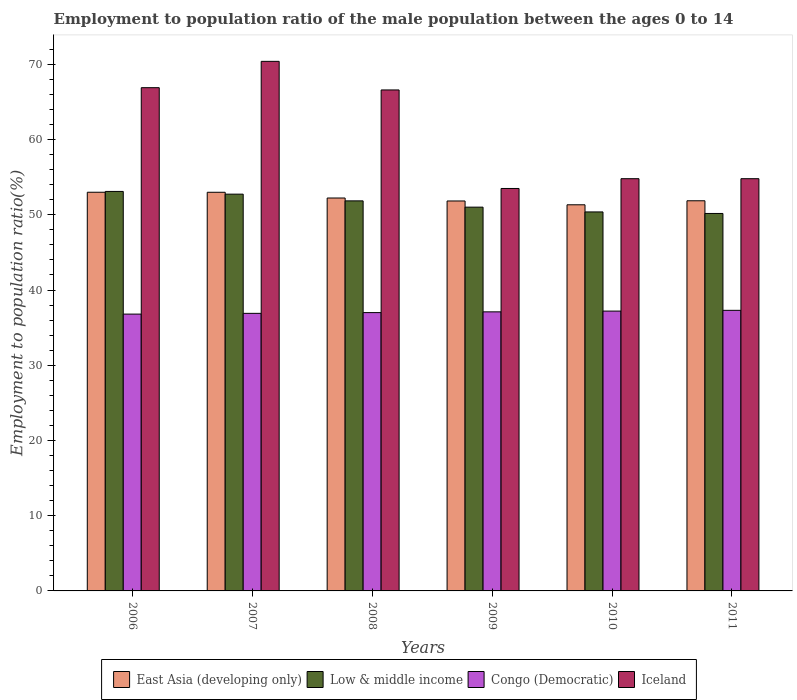How many different coloured bars are there?
Offer a very short reply. 4. Are the number of bars per tick equal to the number of legend labels?
Provide a short and direct response. Yes. How many bars are there on the 5th tick from the right?
Offer a terse response. 4. What is the label of the 3rd group of bars from the left?
Your answer should be compact. 2008. What is the employment to population ratio in East Asia (developing only) in 2009?
Ensure brevity in your answer.  51.84. Across all years, what is the maximum employment to population ratio in Congo (Democratic)?
Offer a very short reply. 37.3. Across all years, what is the minimum employment to population ratio in Low & middle income?
Provide a succinct answer. 50.18. In which year was the employment to population ratio in East Asia (developing only) maximum?
Provide a succinct answer. 2006. What is the total employment to population ratio in Iceland in the graph?
Give a very brief answer. 367. What is the difference between the employment to population ratio in Low & middle income in 2010 and that in 2011?
Your answer should be compact. 0.21. What is the difference between the employment to population ratio in Iceland in 2008 and the employment to population ratio in Congo (Democratic) in 2007?
Give a very brief answer. 29.7. What is the average employment to population ratio in Low & middle income per year?
Your answer should be very brief. 51.55. In the year 2010, what is the difference between the employment to population ratio in Iceland and employment to population ratio in East Asia (developing only)?
Your response must be concise. 3.47. What is the ratio of the employment to population ratio in East Asia (developing only) in 2007 to that in 2008?
Keep it short and to the point. 1.01. Is the employment to population ratio in East Asia (developing only) in 2007 less than that in 2009?
Offer a terse response. No. What is the difference between the highest and the second highest employment to population ratio in East Asia (developing only)?
Offer a very short reply. 0. What is the difference between the highest and the lowest employment to population ratio in East Asia (developing only)?
Provide a short and direct response. 1.67. In how many years, is the employment to population ratio in Iceland greater than the average employment to population ratio in Iceland taken over all years?
Provide a succinct answer. 3. Is it the case that in every year, the sum of the employment to population ratio in East Asia (developing only) and employment to population ratio in Congo (Democratic) is greater than the sum of employment to population ratio in Iceland and employment to population ratio in Low & middle income?
Your answer should be very brief. No. What does the 1st bar from the left in 2007 represents?
Your answer should be compact. East Asia (developing only). What does the 3rd bar from the right in 2006 represents?
Your answer should be compact. Low & middle income. Is it the case that in every year, the sum of the employment to population ratio in Iceland and employment to population ratio in East Asia (developing only) is greater than the employment to population ratio in Congo (Democratic)?
Your answer should be very brief. Yes. Are the values on the major ticks of Y-axis written in scientific E-notation?
Make the answer very short. No. Does the graph contain any zero values?
Your answer should be very brief. No. Where does the legend appear in the graph?
Offer a very short reply. Bottom center. How are the legend labels stacked?
Ensure brevity in your answer.  Horizontal. What is the title of the graph?
Your answer should be very brief. Employment to population ratio of the male population between the ages 0 to 14. Does "Oman" appear as one of the legend labels in the graph?
Provide a short and direct response. No. What is the label or title of the Y-axis?
Keep it short and to the point. Employment to population ratio(%). What is the Employment to population ratio(%) of East Asia (developing only) in 2006?
Ensure brevity in your answer.  53. What is the Employment to population ratio(%) of Low & middle income in 2006?
Offer a terse response. 53.11. What is the Employment to population ratio(%) of Congo (Democratic) in 2006?
Keep it short and to the point. 36.8. What is the Employment to population ratio(%) in Iceland in 2006?
Provide a short and direct response. 66.9. What is the Employment to population ratio(%) in East Asia (developing only) in 2007?
Your answer should be compact. 53. What is the Employment to population ratio(%) in Low & middle income in 2007?
Your response must be concise. 52.75. What is the Employment to population ratio(%) of Congo (Democratic) in 2007?
Your answer should be very brief. 36.9. What is the Employment to population ratio(%) in Iceland in 2007?
Make the answer very short. 70.4. What is the Employment to population ratio(%) of East Asia (developing only) in 2008?
Offer a very short reply. 52.23. What is the Employment to population ratio(%) in Low & middle income in 2008?
Your answer should be compact. 51.85. What is the Employment to population ratio(%) of Iceland in 2008?
Give a very brief answer. 66.6. What is the Employment to population ratio(%) in East Asia (developing only) in 2009?
Give a very brief answer. 51.84. What is the Employment to population ratio(%) in Low & middle income in 2009?
Keep it short and to the point. 51.02. What is the Employment to population ratio(%) in Congo (Democratic) in 2009?
Your answer should be very brief. 37.1. What is the Employment to population ratio(%) of Iceland in 2009?
Offer a terse response. 53.5. What is the Employment to population ratio(%) of East Asia (developing only) in 2010?
Your answer should be compact. 51.33. What is the Employment to population ratio(%) in Low & middle income in 2010?
Offer a very short reply. 50.38. What is the Employment to population ratio(%) of Congo (Democratic) in 2010?
Your response must be concise. 37.2. What is the Employment to population ratio(%) of Iceland in 2010?
Make the answer very short. 54.8. What is the Employment to population ratio(%) of East Asia (developing only) in 2011?
Provide a short and direct response. 51.87. What is the Employment to population ratio(%) of Low & middle income in 2011?
Your answer should be compact. 50.18. What is the Employment to population ratio(%) of Congo (Democratic) in 2011?
Offer a very short reply. 37.3. What is the Employment to population ratio(%) of Iceland in 2011?
Ensure brevity in your answer.  54.8. Across all years, what is the maximum Employment to population ratio(%) of East Asia (developing only)?
Keep it short and to the point. 53. Across all years, what is the maximum Employment to population ratio(%) in Low & middle income?
Provide a succinct answer. 53.11. Across all years, what is the maximum Employment to population ratio(%) in Congo (Democratic)?
Offer a very short reply. 37.3. Across all years, what is the maximum Employment to population ratio(%) of Iceland?
Ensure brevity in your answer.  70.4. Across all years, what is the minimum Employment to population ratio(%) of East Asia (developing only)?
Your response must be concise. 51.33. Across all years, what is the minimum Employment to population ratio(%) of Low & middle income?
Make the answer very short. 50.18. Across all years, what is the minimum Employment to population ratio(%) of Congo (Democratic)?
Ensure brevity in your answer.  36.8. Across all years, what is the minimum Employment to population ratio(%) in Iceland?
Offer a terse response. 53.5. What is the total Employment to population ratio(%) in East Asia (developing only) in the graph?
Provide a succinct answer. 313.27. What is the total Employment to population ratio(%) in Low & middle income in the graph?
Your response must be concise. 309.29. What is the total Employment to population ratio(%) in Congo (Democratic) in the graph?
Keep it short and to the point. 222.3. What is the total Employment to population ratio(%) of Iceland in the graph?
Your answer should be compact. 367. What is the difference between the Employment to population ratio(%) of East Asia (developing only) in 2006 and that in 2007?
Give a very brief answer. 0. What is the difference between the Employment to population ratio(%) of Low & middle income in 2006 and that in 2007?
Offer a very short reply. 0.36. What is the difference between the Employment to population ratio(%) in East Asia (developing only) in 2006 and that in 2008?
Ensure brevity in your answer.  0.77. What is the difference between the Employment to population ratio(%) in Low & middle income in 2006 and that in 2008?
Offer a very short reply. 1.26. What is the difference between the Employment to population ratio(%) in Congo (Democratic) in 2006 and that in 2008?
Your response must be concise. -0.2. What is the difference between the Employment to population ratio(%) of Iceland in 2006 and that in 2008?
Your answer should be very brief. 0.3. What is the difference between the Employment to population ratio(%) in East Asia (developing only) in 2006 and that in 2009?
Give a very brief answer. 1.16. What is the difference between the Employment to population ratio(%) of Low & middle income in 2006 and that in 2009?
Give a very brief answer. 2.09. What is the difference between the Employment to population ratio(%) in Congo (Democratic) in 2006 and that in 2009?
Keep it short and to the point. -0.3. What is the difference between the Employment to population ratio(%) in East Asia (developing only) in 2006 and that in 2010?
Give a very brief answer. 1.67. What is the difference between the Employment to population ratio(%) in Low & middle income in 2006 and that in 2010?
Offer a very short reply. 2.72. What is the difference between the Employment to population ratio(%) in Congo (Democratic) in 2006 and that in 2010?
Make the answer very short. -0.4. What is the difference between the Employment to population ratio(%) of East Asia (developing only) in 2006 and that in 2011?
Your answer should be compact. 1.13. What is the difference between the Employment to population ratio(%) of Low & middle income in 2006 and that in 2011?
Offer a very short reply. 2.93. What is the difference between the Employment to population ratio(%) of Iceland in 2006 and that in 2011?
Provide a succinct answer. 12.1. What is the difference between the Employment to population ratio(%) in East Asia (developing only) in 2007 and that in 2008?
Make the answer very short. 0.76. What is the difference between the Employment to population ratio(%) in Low & middle income in 2007 and that in 2008?
Make the answer very short. 0.89. What is the difference between the Employment to population ratio(%) in Iceland in 2007 and that in 2008?
Ensure brevity in your answer.  3.8. What is the difference between the Employment to population ratio(%) of East Asia (developing only) in 2007 and that in 2009?
Provide a short and direct response. 1.16. What is the difference between the Employment to population ratio(%) in Low & middle income in 2007 and that in 2009?
Provide a short and direct response. 1.73. What is the difference between the Employment to population ratio(%) in Congo (Democratic) in 2007 and that in 2009?
Make the answer very short. -0.2. What is the difference between the Employment to population ratio(%) of Iceland in 2007 and that in 2009?
Provide a short and direct response. 16.9. What is the difference between the Employment to population ratio(%) of East Asia (developing only) in 2007 and that in 2010?
Provide a short and direct response. 1.66. What is the difference between the Employment to population ratio(%) in Low & middle income in 2007 and that in 2010?
Your response must be concise. 2.36. What is the difference between the Employment to population ratio(%) in Iceland in 2007 and that in 2010?
Keep it short and to the point. 15.6. What is the difference between the Employment to population ratio(%) in East Asia (developing only) in 2007 and that in 2011?
Offer a terse response. 1.13. What is the difference between the Employment to population ratio(%) in Low & middle income in 2007 and that in 2011?
Offer a terse response. 2.57. What is the difference between the Employment to population ratio(%) of East Asia (developing only) in 2008 and that in 2009?
Your answer should be very brief. 0.39. What is the difference between the Employment to population ratio(%) of Low & middle income in 2008 and that in 2009?
Your answer should be compact. 0.83. What is the difference between the Employment to population ratio(%) in Iceland in 2008 and that in 2009?
Provide a short and direct response. 13.1. What is the difference between the Employment to population ratio(%) of East Asia (developing only) in 2008 and that in 2010?
Offer a very short reply. 0.9. What is the difference between the Employment to population ratio(%) of Low & middle income in 2008 and that in 2010?
Ensure brevity in your answer.  1.47. What is the difference between the Employment to population ratio(%) in Iceland in 2008 and that in 2010?
Ensure brevity in your answer.  11.8. What is the difference between the Employment to population ratio(%) of East Asia (developing only) in 2008 and that in 2011?
Your answer should be compact. 0.37. What is the difference between the Employment to population ratio(%) in Low & middle income in 2008 and that in 2011?
Offer a very short reply. 1.67. What is the difference between the Employment to population ratio(%) in Congo (Democratic) in 2008 and that in 2011?
Offer a terse response. -0.3. What is the difference between the Employment to population ratio(%) of Iceland in 2008 and that in 2011?
Your answer should be very brief. 11.8. What is the difference between the Employment to population ratio(%) in East Asia (developing only) in 2009 and that in 2010?
Offer a terse response. 0.51. What is the difference between the Employment to population ratio(%) in Low & middle income in 2009 and that in 2010?
Give a very brief answer. 0.63. What is the difference between the Employment to population ratio(%) of Iceland in 2009 and that in 2010?
Offer a terse response. -1.3. What is the difference between the Employment to population ratio(%) in East Asia (developing only) in 2009 and that in 2011?
Keep it short and to the point. -0.03. What is the difference between the Employment to population ratio(%) in Low & middle income in 2009 and that in 2011?
Provide a short and direct response. 0.84. What is the difference between the Employment to population ratio(%) of East Asia (developing only) in 2010 and that in 2011?
Offer a terse response. -0.53. What is the difference between the Employment to population ratio(%) of Low & middle income in 2010 and that in 2011?
Offer a terse response. 0.21. What is the difference between the Employment to population ratio(%) of East Asia (developing only) in 2006 and the Employment to population ratio(%) of Low & middle income in 2007?
Your answer should be compact. 0.25. What is the difference between the Employment to population ratio(%) in East Asia (developing only) in 2006 and the Employment to population ratio(%) in Congo (Democratic) in 2007?
Make the answer very short. 16.1. What is the difference between the Employment to population ratio(%) of East Asia (developing only) in 2006 and the Employment to population ratio(%) of Iceland in 2007?
Give a very brief answer. -17.4. What is the difference between the Employment to population ratio(%) of Low & middle income in 2006 and the Employment to population ratio(%) of Congo (Democratic) in 2007?
Your answer should be very brief. 16.21. What is the difference between the Employment to population ratio(%) in Low & middle income in 2006 and the Employment to population ratio(%) in Iceland in 2007?
Your answer should be very brief. -17.29. What is the difference between the Employment to population ratio(%) of Congo (Democratic) in 2006 and the Employment to population ratio(%) of Iceland in 2007?
Offer a terse response. -33.6. What is the difference between the Employment to population ratio(%) in East Asia (developing only) in 2006 and the Employment to population ratio(%) in Low & middle income in 2008?
Give a very brief answer. 1.15. What is the difference between the Employment to population ratio(%) in East Asia (developing only) in 2006 and the Employment to population ratio(%) in Congo (Democratic) in 2008?
Your answer should be compact. 16. What is the difference between the Employment to population ratio(%) in East Asia (developing only) in 2006 and the Employment to population ratio(%) in Iceland in 2008?
Make the answer very short. -13.6. What is the difference between the Employment to population ratio(%) of Low & middle income in 2006 and the Employment to population ratio(%) of Congo (Democratic) in 2008?
Your answer should be compact. 16.11. What is the difference between the Employment to population ratio(%) in Low & middle income in 2006 and the Employment to population ratio(%) in Iceland in 2008?
Your answer should be very brief. -13.49. What is the difference between the Employment to population ratio(%) in Congo (Democratic) in 2006 and the Employment to population ratio(%) in Iceland in 2008?
Give a very brief answer. -29.8. What is the difference between the Employment to population ratio(%) in East Asia (developing only) in 2006 and the Employment to population ratio(%) in Low & middle income in 2009?
Provide a succinct answer. 1.98. What is the difference between the Employment to population ratio(%) of East Asia (developing only) in 2006 and the Employment to population ratio(%) of Congo (Democratic) in 2009?
Offer a terse response. 15.9. What is the difference between the Employment to population ratio(%) of East Asia (developing only) in 2006 and the Employment to population ratio(%) of Iceland in 2009?
Provide a short and direct response. -0.5. What is the difference between the Employment to population ratio(%) in Low & middle income in 2006 and the Employment to population ratio(%) in Congo (Democratic) in 2009?
Ensure brevity in your answer.  16.01. What is the difference between the Employment to population ratio(%) of Low & middle income in 2006 and the Employment to population ratio(%) of Iceland in 2009?
Ensure brevity in your answer.  -0.39. What is the difference between the Employment to population ratio(%) of Congo (Democratic) in 2006 and the Employment to population ratio(%) of Iceland in 2009?
Provide a succinct answer. -16.7. What is the difference between the Employment to population ratio(%) of East Asia (developing only) in 2006 and the Employment to population ratio(%) of Low & middle income in 2010?
Your answer should be very brief. 2.62. What is the difference between the Employment to population ratio(%) of East Asia (developing only) in 2006 and the Employment to population ratio(%) of Congo (Democratic) in 2010?
Give a very brief answer. 15.8. What is the difference between the Employment to population ratio(%) of East Asia (developing only) in 2006 and the Employment to population ratio(%) of Iceland in 2010?
Offer a very short reply. -1.8. What is the difference between the Employment to population ratio(%) in Low & middle income in 2006 and the Employment to population ratio(%) in Congo (Democratic) in 2010?
Offer a terse response. 15.91. What is the difference between the Employment to population ratio(%) in Low & middle income in 2006 and the Employment to population ratio(%) in Iceland in 2010?
Your response must be concise. -1.69. What is the difference between the Employment to population ratio(%) in Congo (Democratic) in 2006 and the Employment to population ratio(%) in Iceland in 2010?
Give a very brief answer. -18. What is the difference between the Employment to population ratio(%) of East Asia (developing only) in 2006 and the Employment to population ratio(%) of Low & middle income in 2011?
Your response must be concise. 2.82. What is the difference between the Employment to population ratio(%) of East Asia (developing only) in 2006 and the Employment to population ratio(%) of Congo (Democratic) in 2011?
Offer a very short reply. 15.7. What is the difference between the Employment to population ratio(%) in East Asia (developing only) in 2006 and the Employment to population ratio(%) in Iceland in 2011?
Ensure brevity in your answer.  -1.8. What is the difference between the Employment to population ratio(%) in Low & middle income in 2006 and the Employment to population ratio(%) in Congo (Democratic) in 2011?
Your answer should be very brief. 15.81. What is the difference between the Employment to population ratio(%) in Low & middle income in 2006 and the Employment to population ratio(%) in Iceland in 2011?
Provide a short and direct response. -1.69. What is the difference between the Employment to population ratio(%) in Congo (Democratic) in 2006 and the Employment to population ratio(%) in Iceland in 2011?
Ensure brevity in your answer.  -18. What is the difference between the Employment to population ratio(%) in East Asia (developing only) in 2007 and the Employment to population ratio(%) in Low & middle income in 2008?
Provide a succinct answer. 1.14. What is the difference between the Employment to population ratio(%) in East Asia (developing only) in 2007 and the Employment to population ratio(%) in Congo (Democratic) in 2008?
Provide a succinct answer. 16. What is the difference between the Employment to population ratio(%) in East Asia (developing only) in 2007 and the Employment to population ratio(%) in Iceland in 2008?
Make the answer very short. -13.6. What is the difference between the Employment to population ratio(%) of Low & middle income in 2007 and the Employment to population ratio(%) of Congo (Democratic) in 2008?
Offer a terse response. 15.75. What is the difference between the Employment to population ratio(%) of Low & middle income in 2007 and the Employment to population ratio(%) of Iceland in 2008?
Ensure brevity in your answer.  -13.85. What is the difference between the Employment to population ratio(%) in Congo (Democratic) in 2007 and the Employment to population ratio(%) in Iceland in 2008?
Provide a succinct answer. -29.7. What is the difference between the Employment to population ratio(%) of East Asia (developing only) in 2007 and the Employment to population ratio(%) of Low & middle income in 2009?
Your response must be concise. 1.98. What is the difference between the Employment to population ratio(%) in East Asia (developing only) in 2007 and the Employment to population ratio(%) in Congo (Democratic) in 2009?
Your answer should be compact. 15.9. What is the difference between the Employment to population ratio(%) in East Asia (developing only) in 2007 and the Employment to population ratio(%) in Iceland in 2009?
Provide a succinct answer. -0.5. What is the difference between the Employment to population ratio(%) of Low & middle income in 2007 and the Employment to population ratio(%) of Congo (Democratic) in 2009?
Ensure brevity in your answer.  15.65. What is the difference between the Employment to population ratio(%) of Low & middle income in 2007 and the Employment to population ratio(%) of Iceland in 2009?
Offer a terse response. -0.75. What is the difference between the Employment to population ratio(%) of Congo (Democratic) in 2007 and the Employment to population ratio(%) of Iceland in 2009?
Give a very brief answer. -16.6. What is the difference between the Employment to population ratio(%) in East Asia (developing only) in 2007 and the Employment to population ratio(%) in Low & middle income in 2010?
Your answer should be compact. 2.61. What is the difference between the Employment to population ratio(%) in East Asia (developing only) in 2007 and the Employment to population ratio(%) in Congo (Democratic) in 2010?
Offer a terse response. 15.8. What is the difference between the Employment to population ratio(%) in East Asia (developing only) in 2007 and the Employment to population ratio(%) in Iceland in 2010?
Your answer should be compact. -1.8. What is the difference between the Employment to population ratio(%) of Low & middle income in 2007 and the Employment to population ratio(%) of Congo (Democratic) in 2010?
Provide a short and direct response. 15.55. What is the difference between the Employment to population ratio(%) of Low & middle income in 2007 and the Employment to population ratio(%) of Iceland in 2010?
Provide a succinct answer. -2.05. What is the difference between the Employment to population ratio(%) in Congo (Democratic) in 2007 and the Employment to population ratio(%) in Iceland in 2010?
Ensure brevity in your answer.  -17.9. What is the difference between the Employment to population ratio(%) in East Asia (developing only) in 2007 and the Employment to population ratio(%) in Low & middle income in 2011?
Give a very brief answer. 2.82. What is the difference between the Employment to population ratio(%) of East Asia (developing only) in 2007 and the Employment to population ratio(%) of Congo (Democratic) in 2011?
Give a very brief answer. 15.7. What is the difference between the Employment to population ratio(%) of East Asia (developing only) in 2007 and the Employment to population ratio(%) of Iceland in 2011?
Give a very brief answer. -1.8. What is the difference between the Employment to population ratio(%) of Low & middle income in 2007 and the Employment to population ratio(%) of Congo (Democratic) in 2011?
Provide a succinct answer. 15.45. What is the difference between the Employment to population ratio(%) in Low & middle income in 2007 and the Employment to population ratio(%) in Iceland in 2011?
Your response must be concise. -2.05. What is the difference between the Employment to population ratio(%) in Congo (Democratic) in 2007 and the Employment to population ratio(%) in Iceland in 2011?
Your answer should be very brief. -17.9. What is the difference between the Employment to population ratio(%) in East Asia (developing only) in 2008 and the Employment to population ratio(%) in Low & middle income in 2009?
Ensure brevity in your answer.  1.22. What is the difference between the Employment to population ratio(%) of East Asia (developing only) in 2008 and the Employment to population ratio(%) of Congo (Democratic) in 2009?
Your answer should be compact. 15.13. What is the difference between the Employment to population ratio(%) in East Asia (developing only) in 2008 and the Employment to population ratio(%) in Iceland in 2009?
Give a very brief answer. -1.27. What is the difference between the Employment to population ratio(%) in Low & middle income in 2008 and the Employment to population ratio(%) in Congo (Democratic) in 2009?
Your answer should be compact. 14.75. What is the difference between the Employment to population ratio(%) of Low & middle income in 2008 and the Employment to population ratio(%) of Iceland in 2009?
Offer a very short reply. -1.65. What is the difference between the Employment to population ratio(%) in Congo (Democratic) in 2008 and the Employment to population ratio(%) in Iceland in 2009?
Your answer should be very brief. -16.5. What is the difference between the Employment to population ratio(%) of East Asia (developing only) in 2008 and the Employment to population ratio(%) of Low & middle income in 2010?
Ensure brevity in your answer.  1.85. What is the difference between the Employment to population ratio(%) in East Asia (developing only) in 2008 and the Employment to population ratio(%) in Congo (Democratic) in 2010?
Offer a terse response. 15.03. What is the difference between the Employment to population ratio(%) of East Asia (developing only) in 2008 and the Employment to population ratio(%) of Iceland in 2010?
Keep it short and to the point. -2.57. What is the difference between the Employment to population ratio(%) of Low & middle income in 2008 and the Employment to population ratio(%) of Congo (Democratic) in 2010?
Provide a short and direct response. 14.65. What is the difference between the Employment to population ratio(%) of Low & middle income in 2008 and the Employment to population ratio(%) of Iceland in 2010?
Provide a succinct answer. -2.95. What is the difference between the Employment to population ratio(%) of Congo (Democratic) in 2008 and the Employment to population ratio(%) of Iceland in 2010?
Your answer should be compact. -17.8. What is the difference between the Employment to population ratio(%) of East Asia (developing only) in 2008 and the Employment to population ratio(%) of Low & middle income in 2011?
Your response must be concise. 2.06. What is the difference between the Employment to population ratio(%) of East Asia (developing only) in 2008 and the Employment to population ratio(%) of Congo (Democratic) in 2011?
Offer a terse response. 14.93. What is the difference between the Employment to population ratio(%) in East Asia (developing only) in 2008 and the Employment to population ratio(%) in Iceland in 2011?
Provide a short and direct response. -2.57. What is the difference between the Employment to population ratio(%) of Low & middle income in 2008 and the Employment to population ratio(%) of Congo (Democratic) in 2011?
Provide a succinct answer. 14.55. What is the difference between the Employment to population ratio(%) of Low & middle income in 2008 and the Employment to population ratio(%) of Iceland in 2011?
Provide a short and direct response. -2.95. What is the difference between the Employment to population ratio(%) in Congo (Democratic) in 2008 and the Employment to population ratio(%) in Iceland in 2011?
Your answer should be very brief. -17.8. What is the difference between the Employment to population ratio(%) in East Asia (developing only) in 2009 and the Employment to population ratio(%) in Low & middle income in 2010?
Provide a short and direct response. 1.46. What is the difference between the Employment to population ratio(%) of East Asia (developing only) in 2009 and the Employment to population ratio(%) of Congo (Democratic) in 2010?
Ensure brevity in your answer.  14.64. What is the difference between the Employment to population ratio(%) in East Asia (developing only) in 2009 and the Employment to population ratio(%) in Iceland in 2010?
Your answer should be compact. -2.96. What is the difference between the Employment to population ratio(%) of Low & middle income in 2009 and the Employment to population ratio(%) of Congo (Democratic) in 2010?
Offer a terse response. 13.82. What is the difference between the Employment to population ratio(%) of Low & middle income in 2009 and the Employment to population ratio(%) of Iceland in 2010?
Your response must be concise. -3.78. What is the difference between the Employment to population ratio(%) of Congo (Democratic) in 2009 and the Employment to population ratio(%) of Iceland in 2010?
Your answer should be compact. -17.7. What is the difference between the Employment to population ratio(%) of East Asia (developing only) in 2009 and the Employment to population ratio(%) of Low & middle income in 2011?
Give a very brief answer. 1.66. What is the difference between the Employment to population ratio(%) in East Asia (developing only) in 2009 and the Employment to population ratio(%) in Congo (Democratic) in 2011?
Your answer should be very brief. 14.54. What is the difference between the Employment to population ratio(%) in East Asia (developing only) in 2009 and the Employment to population ratio(%) in Iceland in 2011?
Your answer should be very brief. -2.96. What is the difference between the Employment to population ratio(%) in Low & middle income in 2009 and the Employment to population ratio(%) in Congo (Democratic) in 2011?
Give a very brief answer. 13.72. What is the difference between the Employment to population ratio(%) of Low & middle income in 2009 and the Employment to population ratio(%) of Iceland in 2011?
Give a very brief answer. -3.78. What is the difference between the Employment to population ratio(%) in Congo (Democratic) in 2009 and the Employment to population ratio(%) in Iceland in 2011?
Your answer should be very brief. -17.7. What is the difference between the Employment to population ratio(%) in East Asia (developing only) in 2010 and the Employment to population ratio(%) in Low & middle income in 2011?
Your answer should be very brief. 1.15. What is the difference between the Employment to population ratio(%) of East Asia (developing only) in 2010 and the Employment to population ratio(%) of Congo (Democratic) in 2011?
Give a very brief answer. 14.03. What is the difference between the Employment to population ratio(%) of East Asia (developing only) in 2010 and the Employment to population ratio(%) of Iceland in 2011?
Keep it short and to the point. -3.47. What is the difference between the Employment to population ratio(%) of Low & middle income in 2010 and the Employment to population ratio(%) of Congo (Democratic) in 2011?
Ensure brevity in your answer.  13.08. What is the difference between the Employment to population ratio(%) of Low & middle income in 2010 and the Employment to population ratio(%) of Iceland in 2011?
Make the answer very short. -4.42. What is the difference between the Employment to population ratio(%) of Congo (Democratic) in 2010 and the Employment to population ratio(%) of Iceland in 2011?
Provide a succinct answer. -17.6. What is the average Employment to population ratio(%) of East Asia (developing only) per year?
Your answer should be very brief. 52.21. What is the average Employment to population ratio(%) in Low & middle income per year?
Your response must be concise. 51.55. What is the average Employment to population ratio(%) in Congo (Democratic) per year?
Your response must be concise. 37.05. What is the average Employment to population ratio(%) in Iceland per year?
Keep it short and to the point. 61.17. In the year 2006, what is the difference between the Employment to population ratio(%) in East Asia (developing only) and Employment to population ratio(%) in Low & middle income?
Make the answer very short. -0.11. In the year 2006, what is the difference between the Employment to population ratio(%) in East Asia (developing only) and Employment to population ratio(%) in Congo (Democratic)?
Provide a short and direct response. 16.2. In the year 2006, what is the difference between the Employment to population ratio(%) of East Asia (developing only) and Employment to population ratio(%) of Iceland?
Ensure brevity in your answer.  -13.9. In the year 2006, what is the difference between the Employment to population ratio(%) of Low & middle income and Employment to population ratio(%) of Congo (Democratic)?
Offer a very short reply. 16.31. In the year 2006, what is the difference between the Employment to population ratio(%) in Low & middle income and Employment to population ratio(%) in Iceland?
Your answer should be very brief. -13.79. In the year 2006, what is the difference between the Employment to population ratio(%) in Congo (Democratic) and Employment to population ratio(%) in Iceland?
Your response must be concise. -30.1. In the year 2007, what is the difference between the Employment to population ratio(%) of East Asia (developing only) and Employment to population ratio(%) of Low & middle income?
Your response must be concise. 0.25. In the year 2007, what is the difference between the Employment to population ratio(%) in East Asia (developing only) and Employment to population ratio(%) in Congo (Democratic)?
Provide a short and direct response. 16.1. In the year 2007, what is the difference between the Employment to population ratio(%) in East Asia (developing only) and Employment to population ratio(%) in Iceland?
Keep it short and to the point. -17.4. In the year 2007, what is the difference between the Employment to population ratio(%) of Low & middle income and Employment to population ratio(%) of Congo (Democratic)?
Offer a very short reply. 15.85. In the year 2007, what is the difference between the Employment to population ratio(%) of Low & middle income and Employment to population ratio(%) of Iceland?
Your answer should be very brief. -17.65. In the year 2007, what is the difference between the Employment to population ratio(%) of Congo (Democratic) and Employment to population ratio(%) of Iceland?
Offer a terse response. -33.5. In the year 2008, what is the difference between the Employment to population ratio(%) in East Asia (developing only) and Employment to population ratio(%) in Low & middle income?
Your answer should be very brief. 0.38. In the year 2008, what is the difference between the Employment to population ratio(%) in East Asia (developing only) and Employment to population ratio(%) in Congo (Democratic)?
Make the answer very short. 15.23. In the year 2008, what is the difference between the Employment to population ratio(%) in East Asia (developing only) and Employment to population ratio(%) in Iceland?
Your answer should be compact. -14.37. In the year 2008, what is the difference between the Employment to population ratio(%) in Low & middle income and Employment to population ratio(%) in Congo (Democratic)?
Your answer should be compact. 14.85. In the year 2008, what is the difference between the Employment to population ratio(%) of Low & middle income and Employment to population ratio(%) of Iceland?
Your answer should be compact. -14.75. In the year 2008, what is the difference between the Employment to population ratio(%) in Congo (Democratic) and Employment to population ratio(%) in Iceland?
Offer a terse response. -29.6. In the year 2009, what is the difference between the Employment to population ratio(%) in East Asia (developing only) and Employment to population ratio(%) in Low & middle income?
Ensure brevity in your answer.  0.82. In the year 2009, what is the difference between the Employment to population ratio(%) of East Asia (developing only) and Employment to population ratio(%) of Congo (Democratic)?
Your answer should be very brief. 14.74. In the year 2009, what is the difference between the Employment to population ratio(%) of East Asia (developing only) and Employment to population ratio(%) of Iceland?
Provide a succinct answer. -1.66. In the year 2009, what is the difference between the Employment to population ratio(%) of Low & middle income and Employment to population ratio(%) of Congo (Democratic)?
Make the answer very short. 13.92. In the year 2009, what is the difference between the Employment to population ratio(%) of Low & middle income and Employment to population ratio(%) of Iceland?
Provide a short and direct response. -2.48. In the year 2009, what is the difference between the Employment to population ratio(%) in Congo (Democratic) and Employment to population ratio(%) in Iceland?
Offer a terse response. -16.4. In the year 2010, what is the difference between the Employment to population ratio(%) of East Asia (developing only) and Employment to population ratio(%) of Low & middle income?
Your answer should be compact. 0.95. In the year 2010, what is the difference between the Employment to population ratio(%) of East Asia (developing only) and Employment to population ratio(%) of Congo (Democratic)?
Your response must be concise. 14.13. In the year 2010, what is the difference between the Employment to population ratio(%) in East Asia (developing only) and Employment to population ratio(%) in Iceland?
Offer a very short reply. -3.47. In the year 2010, what is the difference between the Employment to population ratio(%) of Low & middle income and Employment to population ratio(%) of Congo (Democratic)?
Provide a short and direct response. 13.18. In the year 2010, what is the difference between the Employment to population ratio(%) of Low & middle income and Employment to population ratio(%) of Iceland?
Offer a terse response. -4.42. In the year 2010, what is the difference between the Employment to population ratio(%) in Congo (Democratic) and Employment to population ratio(%) in Iceland?
Your response must be concise. -17.6. In the year 2011, what is the difference between the Employment to population ratio(%) of East Asia (developing only) and Employment to population ratio(%) of Low & middle income?
Your response must be concise. 1.69. In the year 2011, what is the difference between the Employment to population ratio(%) in East Asia (developing only) and Employment to population ratio(%) in Congo (Democratic)?
Offer a terse response. 14.57. In the year 2011, what is the difference between the Employment to population ratio(%) of East Asia (developing only) and Employment to population ratio(%) of Iceland?
Ensure brevity in your answer.  -2.93. In the year 2011, what is the difference between the Employment to population ratio(%) in Low & middle income and Employment to population ratio(%) in Congo (Democratic)?
Keep it short and to the point. 12.88. In the year 2011, what is the difference between the Employment to population ratio(%) of Low & middle income and Employment to population ratio(%) of Iceland?
Ensure brevity in your answer.  -4.62. In the year 2011, what is the difference between the Employment to population ratio(%) of Congo (Democratic) and Employment to population ratio(%) of Iceland?
Give a very brief answer. -17.5. What is the ratio of the Employment to population ratio(%) in Low & middle income in 2006 to that in 2007?
Provide a short and direct response. 1.01. What is the ratio of the Employment to population ratio(%) of Congo (Democratic) in 2006 to that in 2007?
Offer a terse response. 1. What is the ratio of the Employment to population ratio(%) of Iceland in 2006 to that in 2007?
Keep it short and to the point. 0.95. What is the ratio of the Employment to population ratio(%) in East Asia (developing only) in 2006 to that in 2008?
Your answer should be compact. 1.01. What is the ratio of the Employment to population ratio(%) in Low & middle income in 2006 to that in 2008?
Your response must be concise. 1.02. What is the ratio of the Employment to population ratio(%) of Iceland in 2006 to that in 2008?
Provide a short and direct response. 1. What is the ratio of the Employment to population ratio(%) in East Asia (developing only) in 2006 to that in 2009?
Make the answer very short. 1.02. What is the ratio of the Employment to population ratio(%) of Low & middle income in 2006 to that in 2009?
Your answer should be very brief. 1.04. What is the ratio of the Employment to population ratio(%) of Congo (Democratic) in 2006 to that in 2009?
Your answer should be compact. 0.99. What is the ratio of the Employment to population ratio(%) in Iceland in 2006 to that in 2009?
Your answer should be very brief. 1.25. What is the ratio of the Employment to population ratio(%) of East Asia (developing only) in 2006 to that in 2010?
Give a very brief answer. 1.03. What is the ratio of the Employment to population ratio(%) of Low & middle income in 2006 to that in 2010?
Your answer should be very brief. 1.05. What is the ratio of the Employment to population ratio(%) in Iceland in 2006 to that in 2010?
Make the answer very short. 1.22. What is the ratio of the Employment to population ratio(%) of East Asia (developing only) in 2006 to that in 2011?
Your answer should be compact. 1.02. What is the ratio of the Employment to population ratio(%) of Low & middle income in 2006 to that in 2011?
Make the answer very short. 1.06. What is the ratio of the Employment to population ratio(%) of Congo (Democratic) in 2006 to that in 2011?
Provide a short and direct response. 0.99. What is the ratio of the Employment to population ratio(%) in Iceland in 2006 to that in 2011?
Ensure brevity in your answer.  1.22. What is the ratio of the Employment to population ratio(%) in East Asia (developing only) in 2007 to that in 2008?
Provide a short and direct response. 1.01. What is the ratio of the Employment to population ratio(%) of Low & middle income in 2007 to that in 2008?
Provide a short and direct response. 1.02. What is the ratio of the Employment to population ratio(%) of Congo (Democratic) in 2007 to that in 2008?
Keep it short and to the point. 1. What is the ratio of the Employment to population ratio(%) in Iceland in 2007 to that in 2008?
Ensure brevity in your answer.  1.06. What is the ratio of the Employment to population ratio(%) of East Asia (developing only) in 2007 to that in 2009?
Make the answer very short. 1.02. What is the ratio of the Employment to population ratio(%) of Low & middle income in 2007 to that in 2009?
Offer a terse response. 1.03. What is the ratio of the Employment to population ratio(%) in Congo (Democratic) in 2007 to that in 2009?
Provide a short and direct response. 0.99. What is the ratio of the Employment to population ratio(%) of Iceland in 2007 to that in 2009?
Provide a succinct answer. 1.32. What is the ratio of the Employment to population ratio(%) in East Asia (developing only) in 2007 to that in 2010?
Provide a succinct answer. 1.03. What is the ratio of the Employment to population ratio(%) in Low & middle income in 2007 to that in 2010?
Your response must be concise. 1.05. What is the ratio of the Employment to population ratio(%) in Iceland in 2007 to that in 2010?
Your answer should be very brief. 1.28. What is the ratio of the Employment to population ratio(%) in East Asia (developing only) in 2007 to that in 2011?
Your response must be concise. 1.02. What is the ratio of the Employment to population ratio(%) of Low & middle income in 2007 to that in 2011?
Your response must be concise. 1.05. What is the ratio of the Employment to population ratio(%) of Congo (Democratic) in 2007 to that in 2011?
Offer a terse response. 0.99. What is the ratio of the Employment to population ratio(%) of Iceland in 2007 to that in 2011?
Your answer should be compact. 1.28. What is the ratio of the Employment to population ratio(%) in East Asia (developing only) in 2008 to that in 2009?
Ensure brevity in your answer.  1.01. What is the ratio of the Employment to population ratio(%) in Low & middle income in 2008 to that in 2009?
Make the answer very short. 1.02. What is the ratio of the Employment to population ratio(%) of Congo (Democratic) in 2008 to that in 2009?
Offer a terse response. 1. What is the ratio of the Employment to population ratio(%) of Iceland in 2008 to that in 2009?
Ensure brevity in your answer.  1.24. What is the ratio of the Employment to population ratio(%) in East Asia (developing only) in 2008 to that in 2010?
Provide a succinct answer. 1.02. What is the ratio of the Employment to population ratio(%) in Low & middle income in 2008 to that in 2010?
Make the answer very short. 1.03. What is the ratio of the Employment to population ratio(%) of Congo (Democratic) in 2008 to that in 2010?
Offer a very short reply. 0.99. What is the ratio of the Employment to population ratio(%) in Iceland in 2008 to that in 2010?
Provide a short and direct response. 1.22. What is the ratio of the Employment to population ratio(%) in East Asia (developing only) in 2008 to that in 2011?
Your answer should be very brief. 1.01. What is the ratio of the Employment to population ratio(%) in Low & middle income in 2008 to that in 2011?
Give a very brief answer. 1.03. What is the ratio of the Employment to population ratio(%) of Congo (Democratic) in 2008 to that in 2011?
Your answer should be compact. 0.99. What is the ratio of the Employment to population ratio(%) of Iceland in 2008 to that in 2011?
Provide a succinct answer. 1.22. What is the ratio of the Employment to population ratio(%) in East Asia (developing only) in 2009 to that in 2010?
Ensure brevity in your answer.  1.01. What is the ratio of the Employment to population ratio(%) of Low & middle income in 2009 to that in 2010?
Provide a succinct answer. 1.01. What is the ratio of the Employment to population ratio(%) of Iceland in 2009 to that in 2010?
Ensure brevity in your answer.  0.98. What is the ratio of the Employment to population ratio(%) in East Asia (developing only) in 2009 to that in 2011?
Ensure brevity in your answer.  1. What is the ratio of the Employment to population ratio(%) of Low & middle income in 2009 to that in 2011?
Keep it short and to the point. 1.02. What is the ratio of the Employment to population ratio(%) of Congo (Democratic) in 2009 to that in 2011?
Keep it short and to the point. 0.99. What is the ratio of the Employment to population ratio(%) of Iceland in 2009 to that in 2011?
Make the answer very short. 0.98. What is the ratio of the Employment to population ratio(%) of East Asia (developing only) in 2010 to that in 2011?
Keep it short and to the point. 0.99. What is the ratio of the Employment to population ratio(%) in Low & middle income in 2010 to that in 2011?
Make the answer very short. 1. What is the ratio of the Employment to population ratio(%) of Congo (Democratic) in 2010 to that in 2011?
Your answer should be very brief. 1. What is the ratio of the Employment to population ratio(%) of Iceland in 2010 to that in 2011?
Your answer should be compact. 1. What is the difference between the highest and the second highest Employment to population ratio(%) in East Asia (developing only)?
Provide a short and direct response. 0. What is the difference between the highest and the second highest Employment to population ratio(%) in Low & middle income?
Provide a succinct answer. 0.36. What is the difference between the highest and the second highest Employment to population ratio(%) of Congo (Democratic)?
Offer a very short reply. 0.1. What is the difference between the highest and the lowest Employment to population ratio(%) in East Asia (developing only)?
Provide a succinct answer. 1.67. What is the difference between the highest and the lowest Employment to population ratio(%) in Low & middle income?
Offer a terse response. 2.93. 